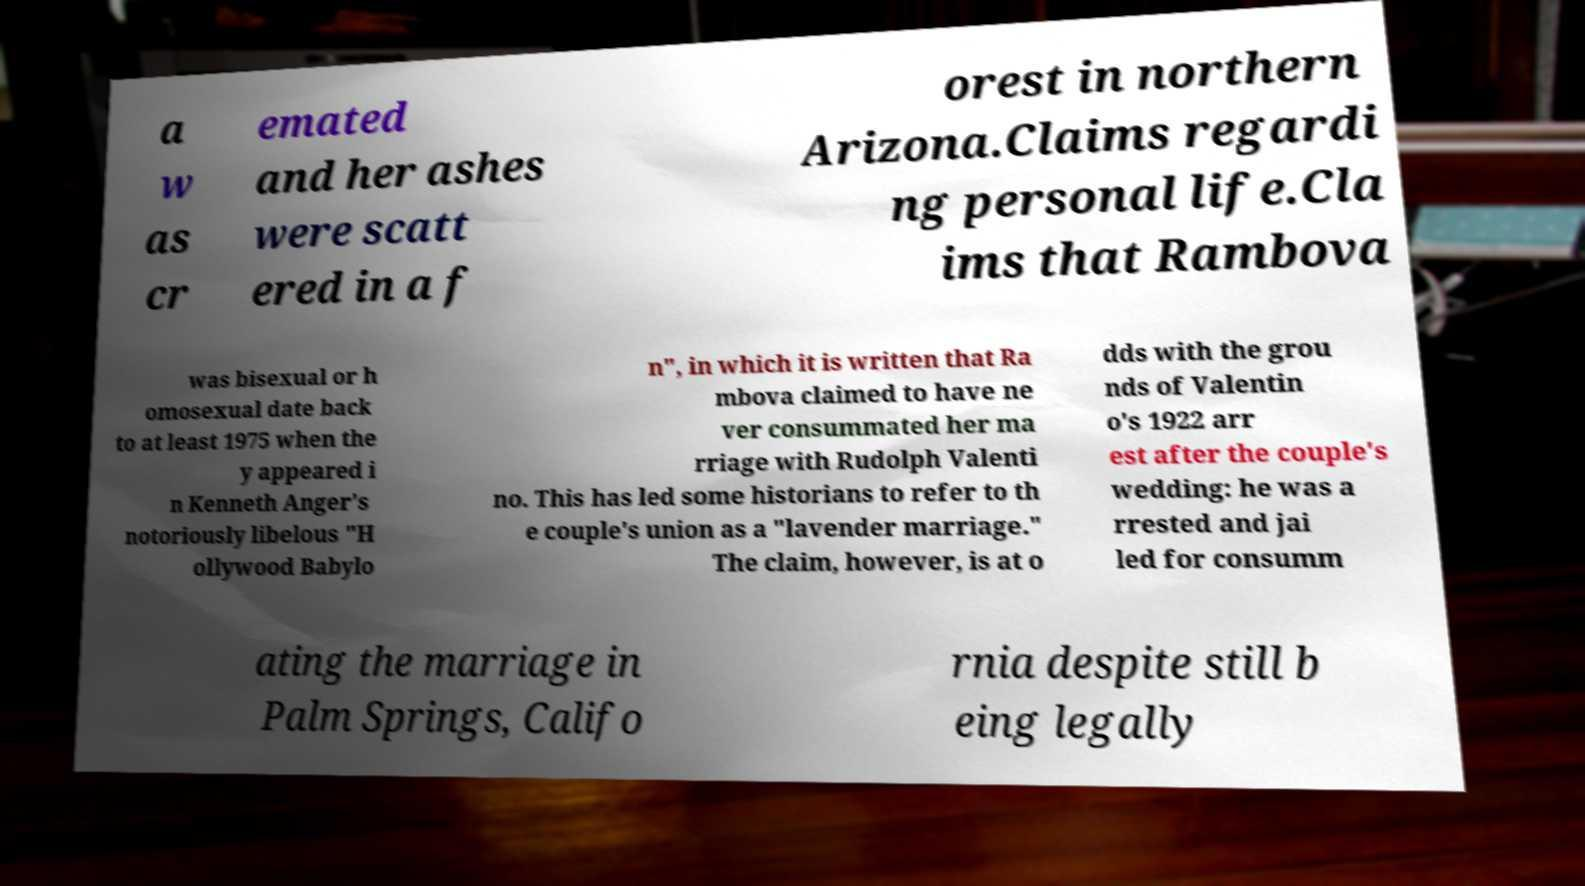For documentation purposes, I need the text within this image transcribed. Could you provide that? a w as cr emated and her ashes were scatt ered in a f orest in northern Arizona.Claims regardi ng personal life.Cla ims that Rambova was bisexual or h omosexual date back to at least 1975 when the y appeared i n Kenneth Anger's notoriously libelous "H ollywood Babylo n", in which it is written that Ra mbova claimed to have ne ver consummated her ma rriage with Rudolph Valenti no. This has led some historians to refer to th e couple's union as a "lavender marriage." The claim, however, is at o dds with the grou nds of Valentin o's 1922 arr est after the couple's wedding: he was a rrested and jai led for consumm ating the marriage in Palm Springs, Califo rnia despite still b eing legally 